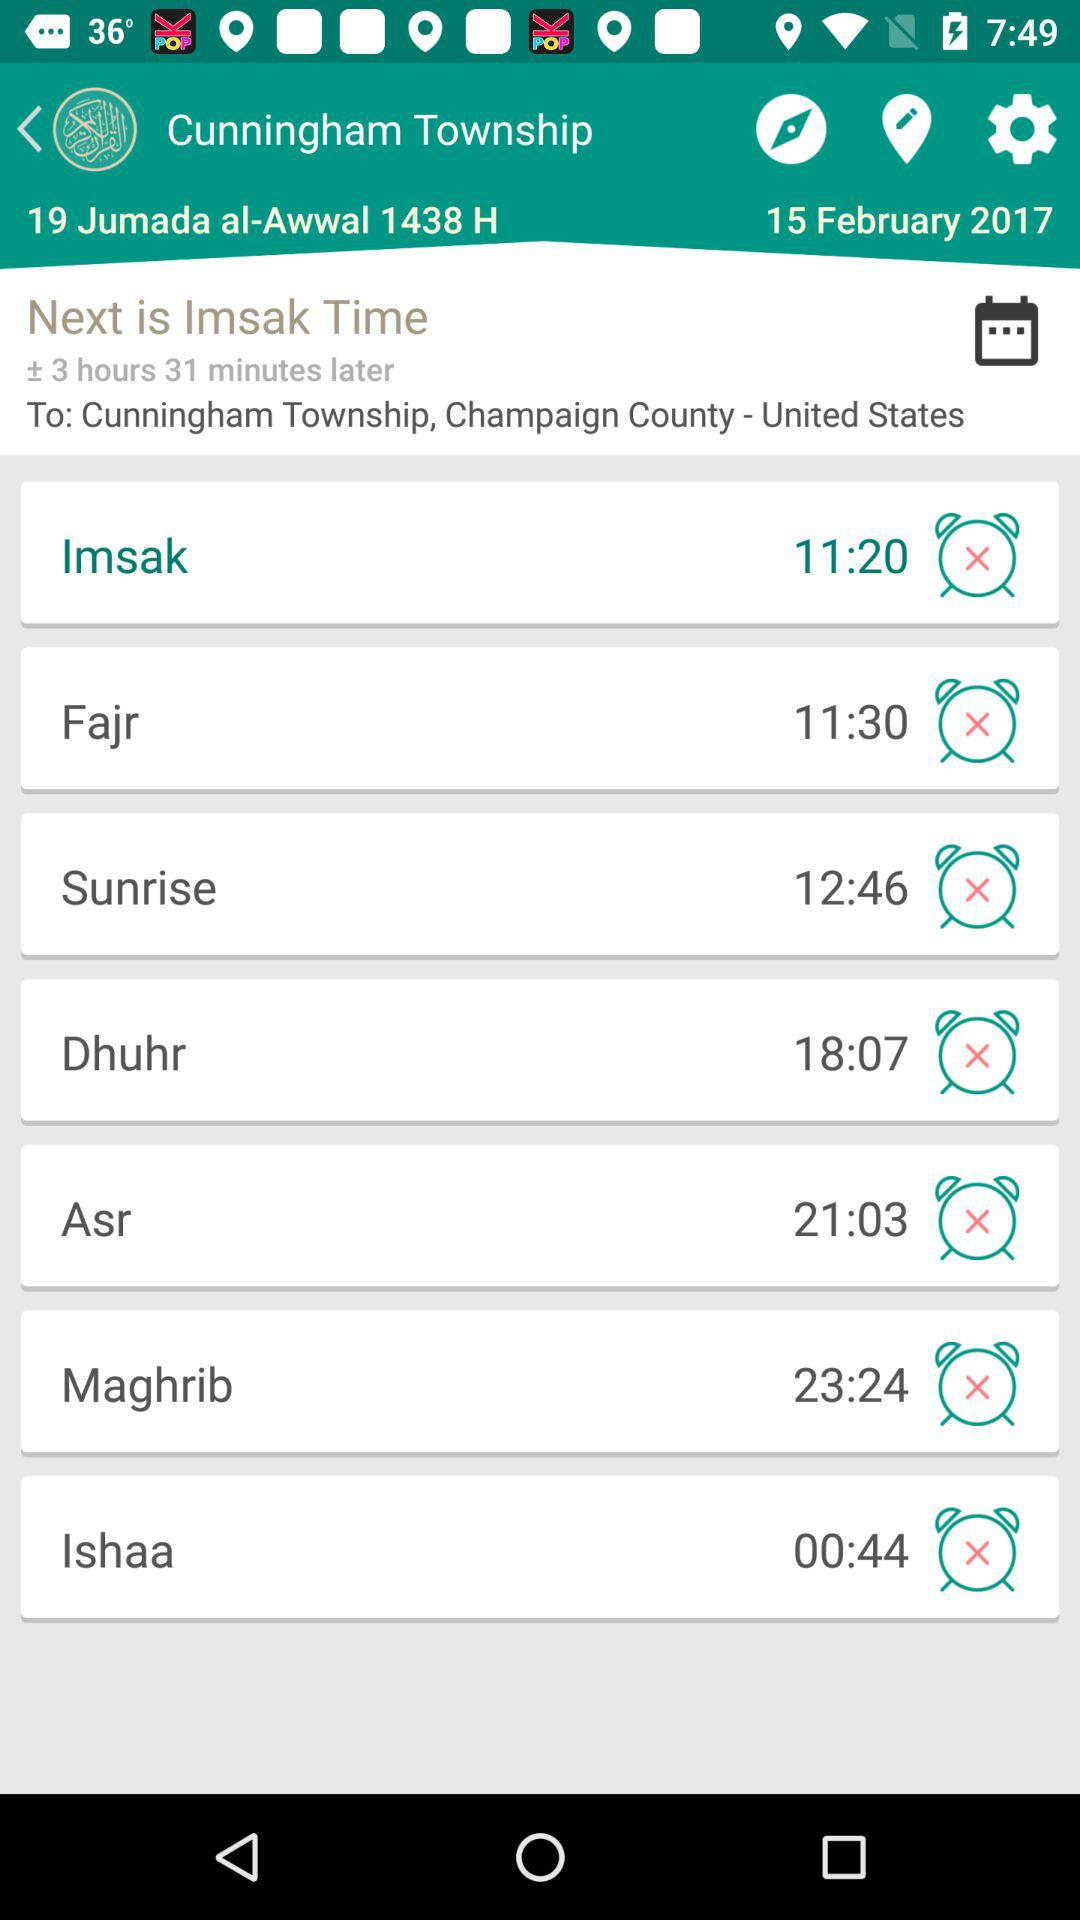How much time remains for "Imsak Time"? The remaining time is 3 hours and 31 minutes. 